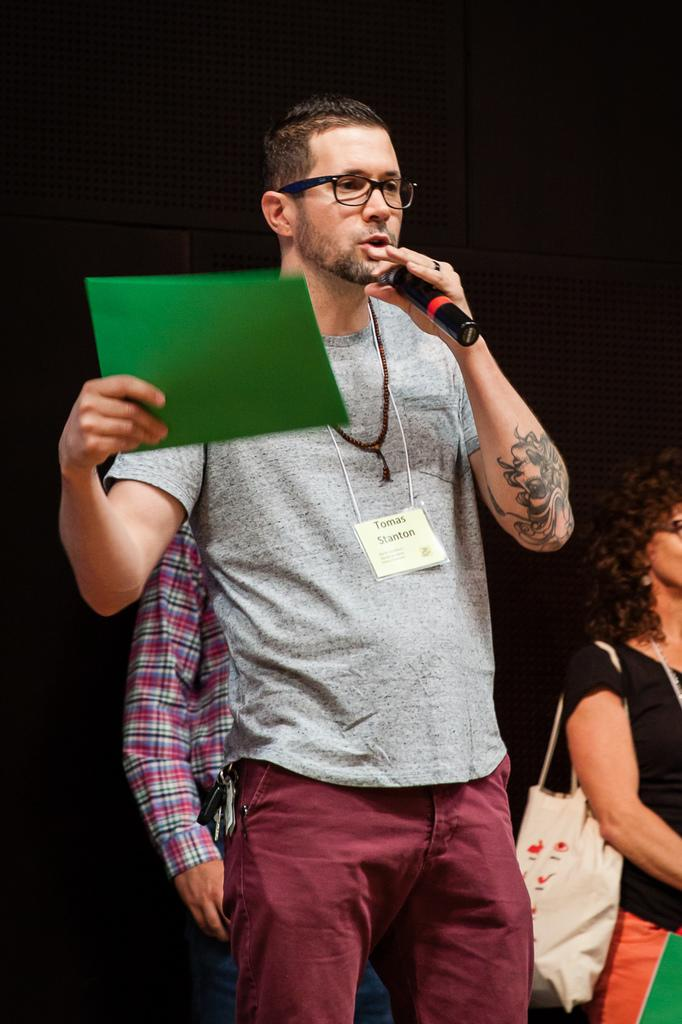What is the man in the center of the image doing? The man is standing in the center of the image and holding a microphone in his left hand and a file in his right hand. What is the man doing with the microphone? The man is talking while holding the microphone. Who else is present in the image? There is a woman on the right side of the image. What rhythm is the man following while holding the microphone in the image? There is no indication of a rhythm in the image; the man is simply talking while holding the microphone. 